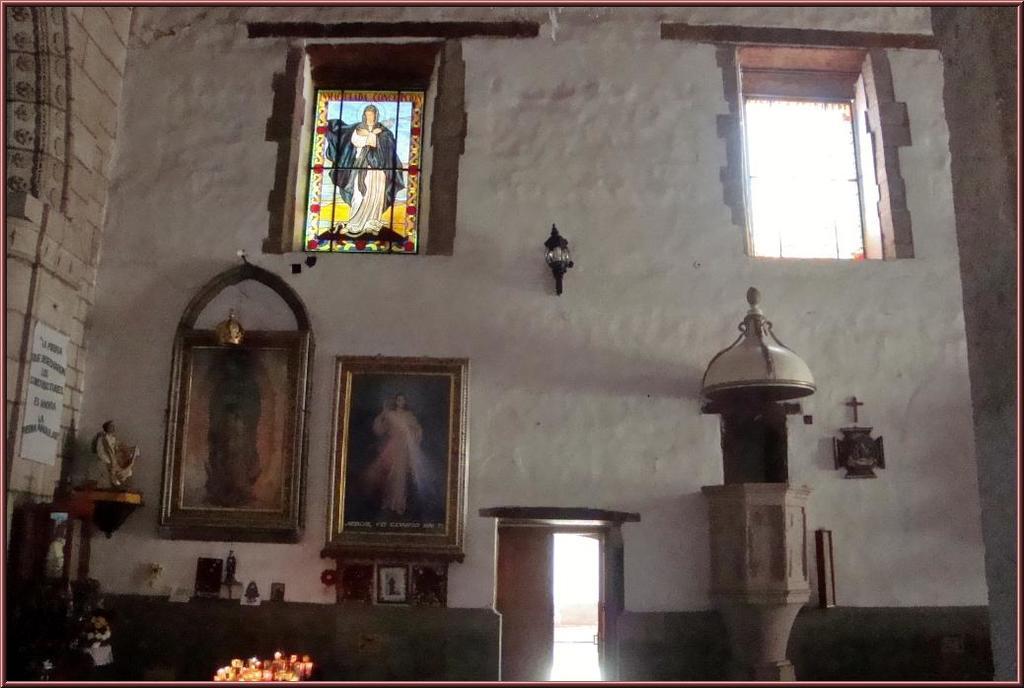Could you give a brief overview of what you see in this image? This image might be taken in church. In this image we can see doors, photo frames, light, windows, statue and wall. 